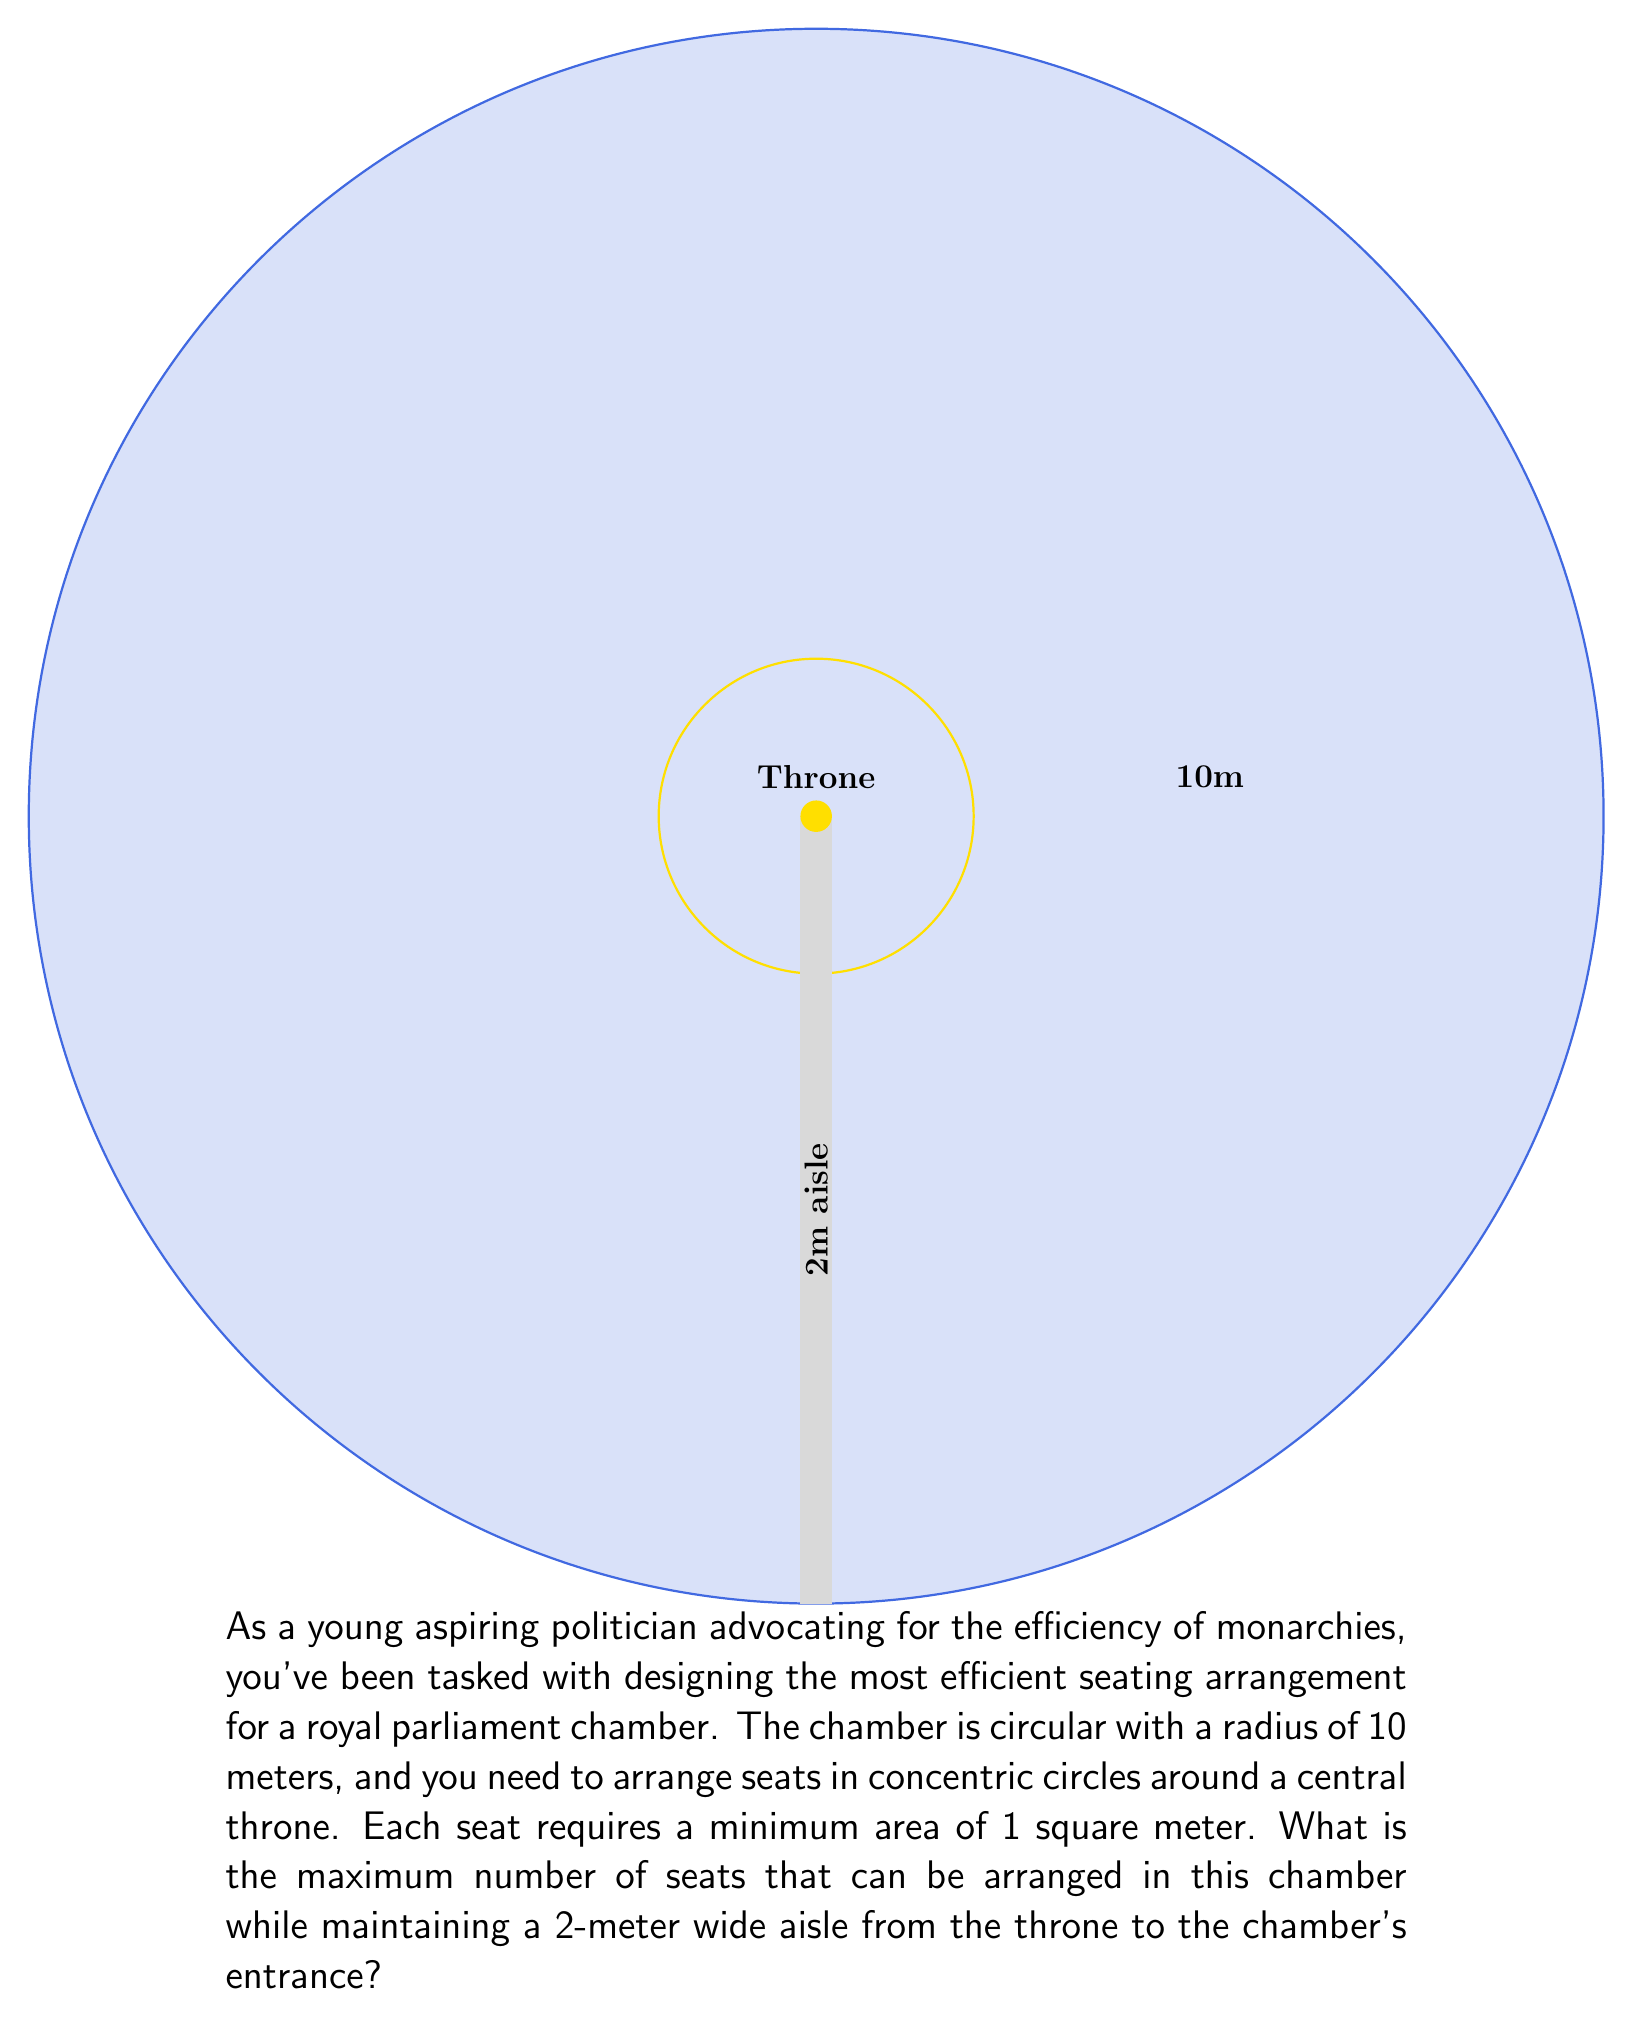Can you solve this math problem? Let's approach this step-by-step:

1) First, we need to calculate the total area of the chamber:
   $$A_{total} = \pi r^2 = \pi \cdot 10^2 = 100\pi \approx 314.16 \text{ m}^2$$

2) Next, we need to subtract the area of the aisle:
   $$A_{aisle} = 2 \cdot 10 = 20 \text{ m}^2$$

3) The remaining area for seating is:
   $$A_{seating} = A_{total} - A_{aisle} = 100\pi - 20 \approx 294.16 \text{ m}^2$$

4) Each seat requires 1 square meter, so theoretically, we could fit 294 seats. However, we need to arrange them in concentric circles.

5) Let's calculate the number of seats in each circle, starting from the innermost circle (just outside the 2m aisle):
   - Circle 1: Circumference = $2\pi(2+1) \approx 18.85$, so we can fit 18 seats
   - Circle 2: Circumference = $2\pi(2+2) \approx 25.13$, so we can fit 25 seats
   - Circle 3: Circumference = $2\pi(2+3) \approx 31.42$, so we can fit 31 seats
   - Circle 4: Circumference = $2\pi(2+4) \approx 37.70$, so we can fit 37 seats
   - Circle 5: Circumference = $2\pi(2+5) \approx 43.98$, so we can fit 43 seats
   - Circle 6: Circumference = $2\pi(2+6) \approx 50.27$, so we can fit 50 seats
   - Circle 7: Circumference = $2\pi(2+7) \approx 56.55$, so we can fit 56 seats

6) Adding up all the seats:
   $$18 + 25 + 31 + 37 + 43 + 50 + 56 = 260 \text{ seats}$$

This arrangement leaves some space near the outer edge, but adding another full circle would exceed the chamber's dimensions.
Answer: 260 seats 